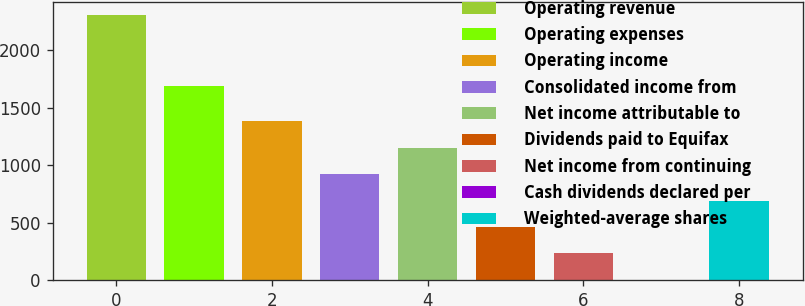Convert chart to OTSL. <chart><loc_0><loc_0><loc_500><loc_500><bar_chart><fcel>Operating revenue<fcel>Operating expenses<fcel>Operating income<fcel>Consolidated income from<fcel>Net income attributable to<fcel>Dividends paid to Equifax<fcel>Net income from continuing<fcel>Cash dividends declared per<fcel>Weighted-average shares<nl><fcel>2303.9<fcel>1692.7<fcel>1382.68<fcel>922.08<fcel>1152.38<fcel>461.48<fcel>231.18<fcel>0.88<fcel>691.78<nl></chart> 